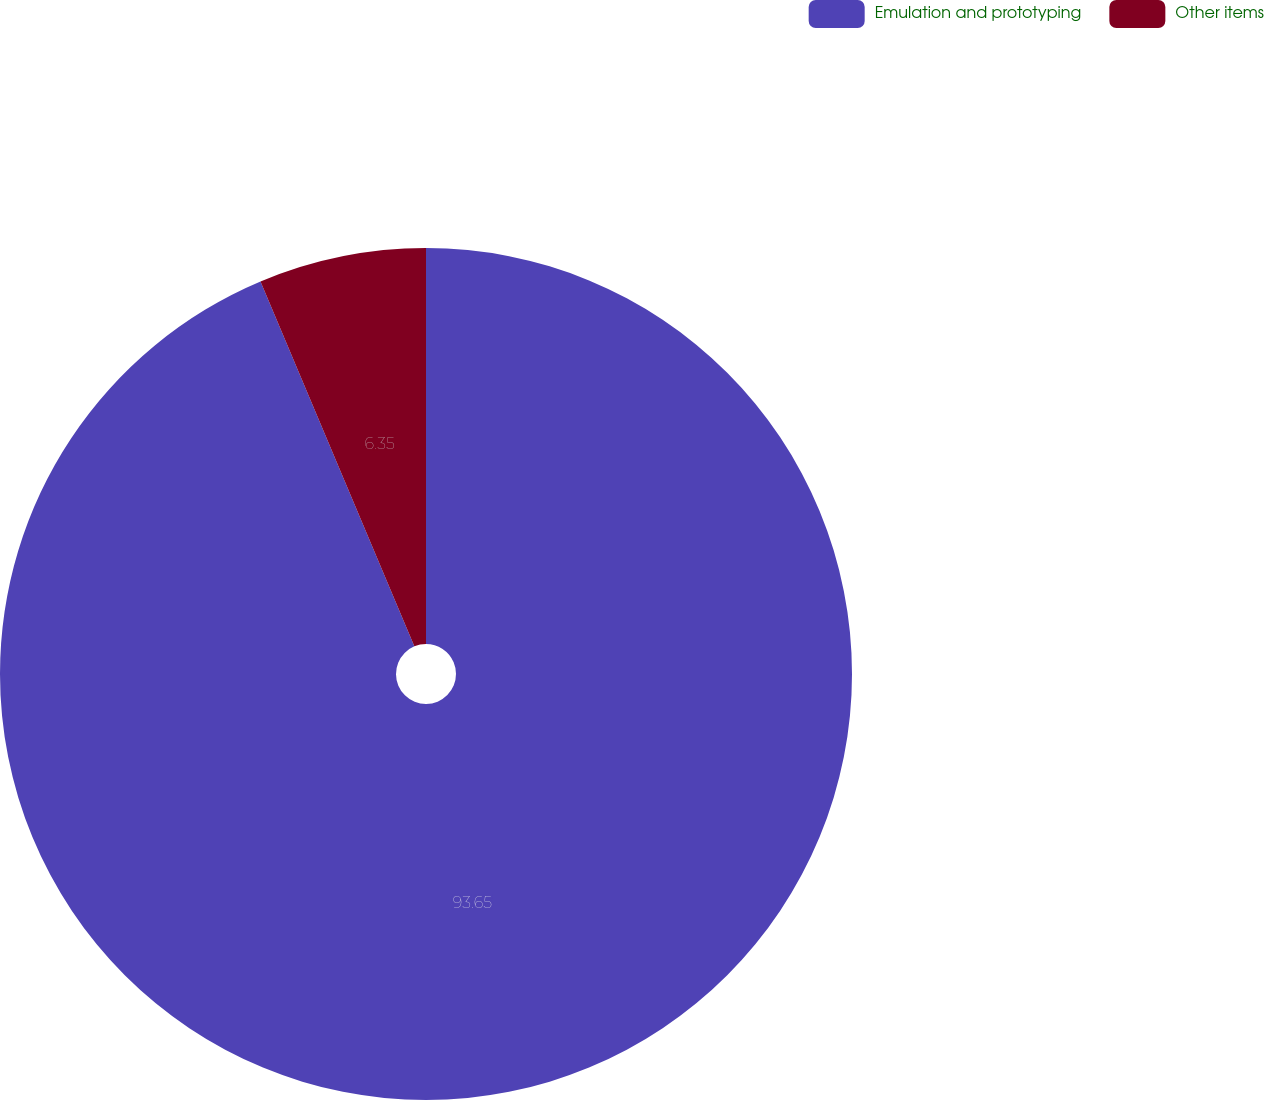Convert chart to OTSL. <chart><loc_0><loc_0><loc_500><loc_500><pie_chart><fcel>Emulation and prototyping<fcel>Other items<nl><fcel>93.65%<fcel>6.35%<nl></chart> 